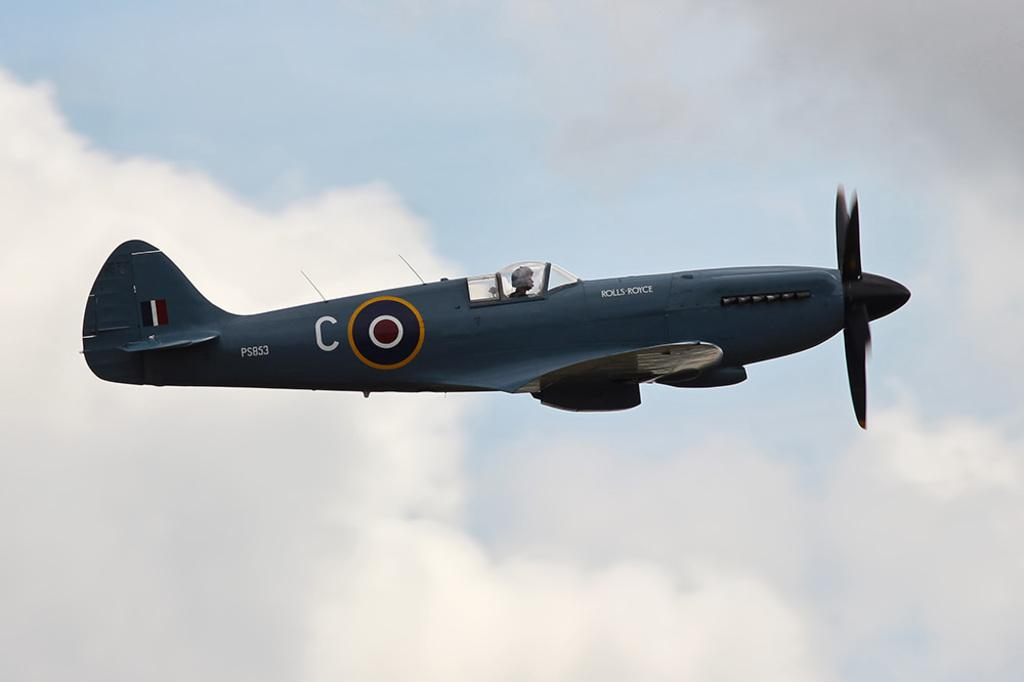<image>
Describe the image concisely. A military plane with the call numbers PS853 flies through the air. 